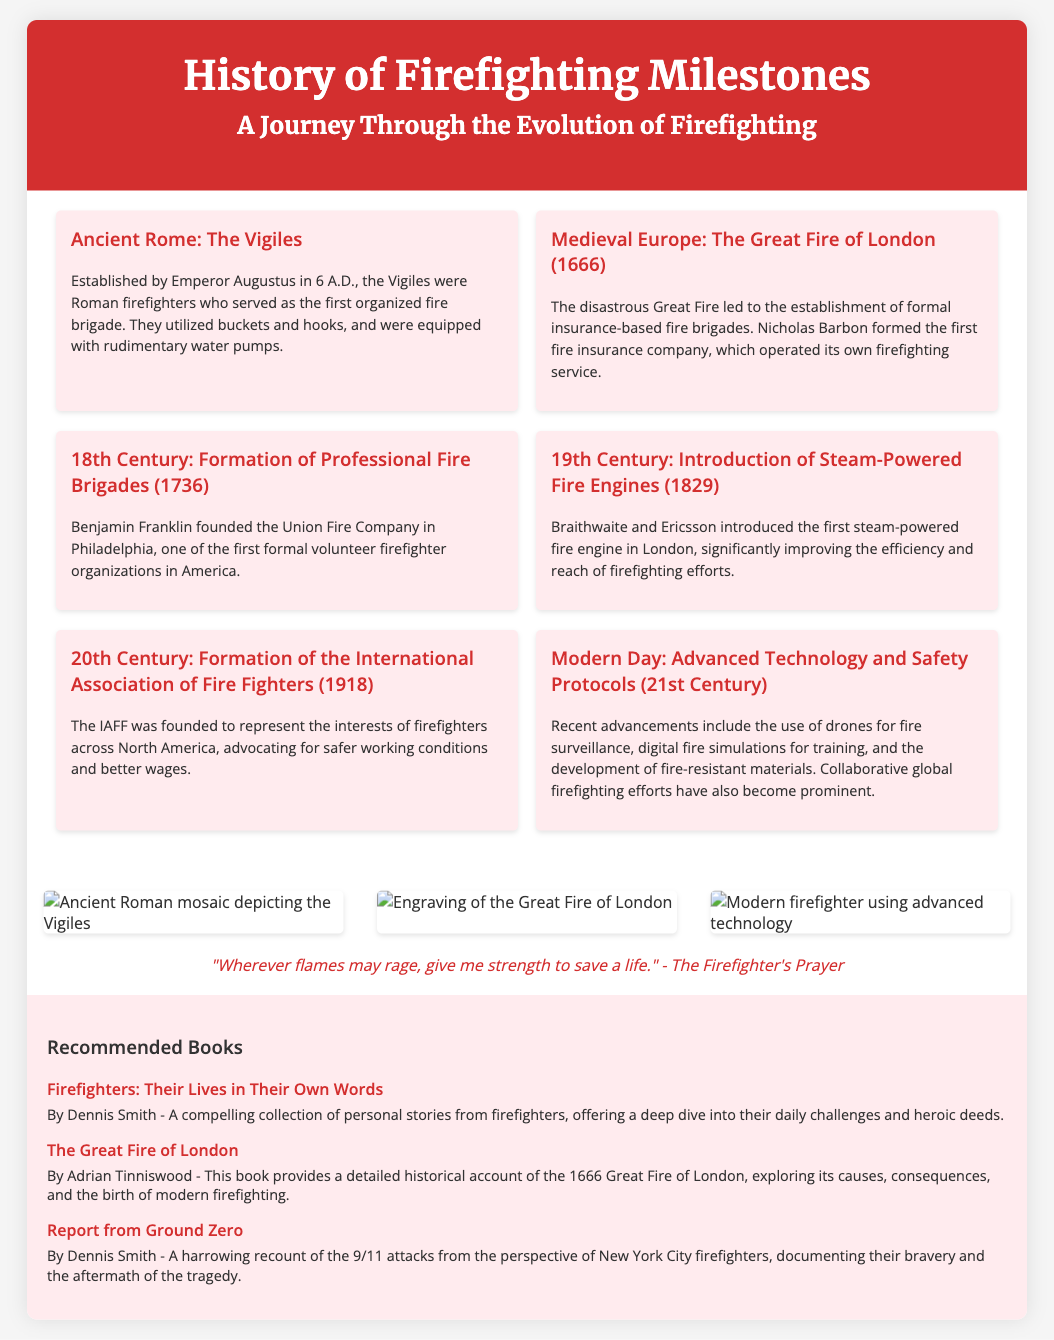What year was the Vigiles established? The Vigiles were established by Emperor Augustus in 6 A.D.
Answer: 6 A.D Who founded the Union Fire Company? The Union Fire Company was founded by Benjamin Franklin in Philadelphia.
Answer: Benjamin Franklin What significant event happened in 1666? The Great Fire of London occurred in 1666.
Answer: Great Fire of London What type of fire engine was introduced in 1829? The first steam-powered fire engine was introduced in 1829.
Answer: Steam-powered fire engine Which organization's formation in 1918 aimed to represent firefighters? The International Association of Fire Fighters (IAFF) was formed in 1918.
Answer: IAFF What does the Firefighter's Prayer emphasize? The Firefighter's Prayer emphasizes giving strength to save lives.
Answer: Save a life What are some modern advancements mentioned in the poster? Advancements include drones for fire surveillance, digital fire simulations, and fire-resistant materials.
Answer: Drones, digital simulations, fire-resistant materials Which book chronicles personal stories from firefighters? "Firefighters: Their Lives in Their Own Words" chronicles personal stories from firefighters.
Answer: Firefighters: Their Lives in Their Own Words In which century were professional fire brigades formed? Professional fire brigades were formed in the 18th Century.
Answer: 18th Century 